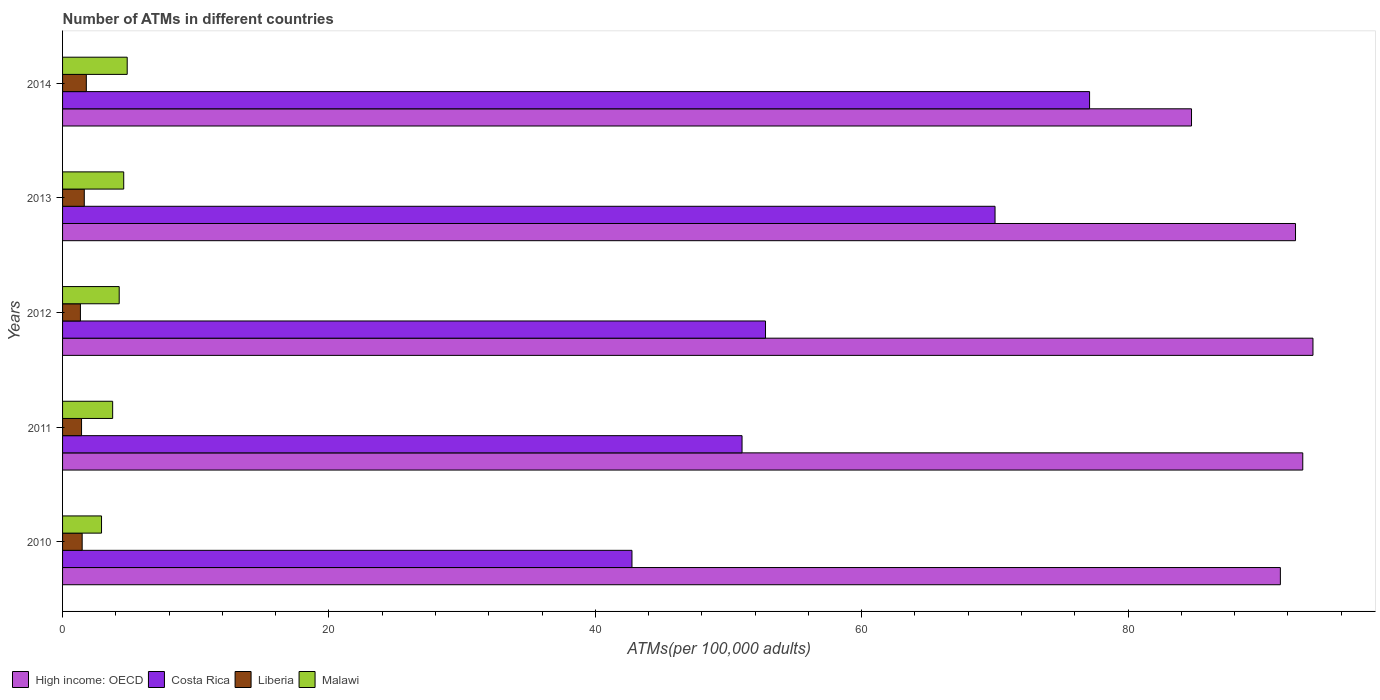Are the number of bars per tick equal to the number of legend labels?
Offer a very short reply. Yes. In how many cases, is the number of bars for a given year not equal to the number of legend labels?
Offer a very short reply. 0. What is the number of ATMs in Liberia in 2010?
Provide a short and direct response. 1.47. Across all years, what is the maximum number of ATMs in Malawi?
Provide a succinct answer. 4.85. Across all years, what is the minimum number of ATMs in Liberia?
Ensure brevity in your answer.  1.34. In which year was the number of ATMs in High income: OECD maximum?
Keep it short and to the point. 2012. What is the total number of ATMs in Liberia in the graph?
Provide a succinct answer. 7.65. What is the difference between the number of ATMs in Liberia in 2011 and that in 2013?
Offer a very short reply. -0.21. What is the difference between the number of ATMs in Malawi in 2014 and the number of ATMs in High income: OECD in 2013?
Provide a succinct answer. -87.72. What is the average number of ATMs in Liberia per year?
Make the answer very short. 1.53. In the year 2012, what is the difference between the number of ATMs in Liberia and number of ATMs in High income: OECD?
Ensure brevity in your answer.  -92.54. What is the ratio of the number of ATMs in Malawi in 2011 to that in 2013?
Keep it short and to the point. 0.82. What is the difference between the highest and the second highest number of ATMs in Liberia?
Give a very brief answer. 0.15. What is the difference between the highest and the lowest number of ATMs in Costa Rica?
Your answer should be very brief. 34.36. In how many years, is the number of ATMs in Costa Rica greater than the average number of ATMs in Costa Rica taken over all years?
Provide a short and direct response. 2. Is the sum of the number of ATMs in Costa Rica in 2011 and 2014 greater than the maximum number of ATMs in Liberia across all years?
Give a very brief answer. Yes. What does the 1st bar from the top in 2014 represents?
Ensure brevity in your answer.  Malawi. What does the 4th bar from the bottom in 2014 represents?
Your answer should be compact. Malawi. Is it the case that in every year, the sum of the number of ATMs in Malawi and number of ATMs in Costa Rica is greater than the number of ATMs in High income: OECD?
Your response must be concise. No. How many years are there in the graph?
Your response must be concise. 5. What is the difference between two consecutive major ticks on the X-axis?
Provide a short and direct response. 20. Are the values on the major ticks of X-axis written in scientific E-notation?
Provide a succinct answer. No. Does the graph contain grids?
Ensure brevity in your answer.  No. Where does the legend appear in the graph?
Offer a very short reply. Bottom left. How many legend labels are there?
Your answer should be compact. 4. How are the legend labels stacked?
Your answer should be very brief. Horizontal. What is the title of the graph?
Your response must be concise. Number of ATMs in different countries. Does "Austria" appear as one of the legend labels in the graph?
Your answer should be compact. No. What is the label or title of the X-axis?
Provide a short and direct response. ATMs(per 100,0 adults). What is the label or title of the Y-axis?
Offer a very short reply. Years. What is the ATMs(per 100,000 adults) in High income: OECD in 2010?
Provide a short and direct response. 91.44. What is the ATMs(per 100,000 adults) of Costa Rica in 2010?
Provide a succinct answer. 42.75. What is the ATMs(per 100,000 adults) of Liberia in 2010?
Offer a terse response. 1.47. What is the ATMs(per 100,000 adults) in Malawi in 2010?
Give a very brief answer. 2.93. What is the ATMs(per 100,000 adults) in High income: OECD in 2011?
Make the answer very short. 93.12. What is the ATMs(per 100,000 adults) of Costa Rica in 2011?
Ensure brevity in your answer.  51.02. What is the ATMs(per 100,000 adults) of Liberia in 2011?
Make the answer very short. 1.42. What is the ATMs(per 100,000 adults) of Malawi in 2011?
Provide a succinct answer. 3.76. What is the ATMs(per 100,000 adults) of High income: OECD in 2012?
Provide a succinct answer. 93.88. What is the ATMs(per 100,000 adults) in Costa Rica in 2012?
Offer a very short reply. 52.78. What is the ATMs(per 100,000 adults) in Liberia in 2012?
Keep it short and to the point. 1.34. What is the ATMs(per 100,000 adults) in Malawi in 2012?
Offer a terse response. 4.25. What is the ATMs(per 100,000 adults) of High income: OECD in 2013?
Make the answer very short. 92.57. What is the ATMs(per 100,000 adults) of Costa Rica in 2013?
Provide a short and direct response. 70.01. What is the ATMs(per 100,000 adults) in Liberia in 2013?
Provide a succinct answer. 1.63. What is the ATMs(per 100,000 adults) of Malawi in 2013?
Ensure brevity in your answer.  4.59. What is the ATMs(per 100,000 adults) of High income: OECD in 2014?
Make the answer very short. 84.77. What is the ATMs(per 100,000 adults) of Costa Rica in 2014?
Keep it short and to the point. 77.11. What is the ATMs(per 100,000 adults) of Liberia in 2014?
Provide a succinct answer. 1.78. What is the ATMs(per 100,000 adults) in Malawi in 2014?
Your response must be concise. 4.85. Across all years, what is the maximum ATMs(per 100,000 adults) in High income: OECD?
Give a very brief answer. 93.88. Across all years, what is the maximum ATMs(per 100,000 adults) of Costa Rica?
Your response must be concise. 77.11. Across all years, what is the maximum ATMs(per 100,000 adults) of Liberia?
Provide a succinct answer. 1.78. Across all years, what is the maximum ATMs(per 100,000 adults) in Malawi?
Provide a short and direct response. 4.85. Across all years, what is the minimum ATMs(per 100,000 adults) in High income: OECD?
Provide a succinct answer. 84.77. Across all years, what is the minimum ATMs(per 100,000 adults) in Costa Rica?
Give a very brief answer. 42.75. Across all years, what is the minimum ATMs(per 100,000 adults) of Liberia?
Provide a succinct answer. 1.34. Across all years, what is the minimum ATMs(per 100,000 adults) in Malawi?
Your answer should be very brief. 2.93. What is the total ATMs(per 100,000 adults) in High income: OECD in the graph?
Your response must be concise. 455.78. What is the total ATMs(per 100,000 adults) in Costa Rica in the graph?
Give a very brief answer. 293.68. What is the total ATMs(per 100,000 adults) of Liberia in the graph?
Provide a succinct answer. 7.65. What is the total ATMs(per 100,000 adults) in Malawi in the graph?
Make the answer very short. 20.38. What is the difference between the ATMs(per 100,000 adults) of High income: OECD in 2010 and that in 2011?
Give a very brief answer. -1.68. What is the difference between the ATMs(per 100,000 adults) in Costa Rica in 2010 and that in 2011?
Provide a succinct answer. -8.26. What is the difference between the ATMs(per 100,000 adults) of Liberia in 2010 and that in 2011?
Ensure brevity in your answer.  0.05. What is the difference between the ATMs(per 100,000 adults) in Malawi in 2010 and that in 2011?
Ensure brevity in your answer.  -0.84. What is the difference between the ATMs(per 100,000 adults) in High income: OECD in 2010 and that in 2012?
Your response must be concise. -2.45. What is the difference between the ATMs(per 100,000 adults) in Costa Rica in 2010 and that in 2012?
Keep it short and to the point. -10.03. What is the difference between the ATMs(per 100,000 adults) in Liberia in 2010 and that in 2012?
Offer a very short reply. 0.13. What is the difference between the ATMs(per 100,000 adults) in Malawi in 2010 and that in 2012?
Your response must be concise. -1.33. What is the difference between the ATMs(per 100,000 adults) of High income: OECD in 2010 and that in 2013?
Provide a succinct answer. -1.14. What is the difference between the ATMs(per 100,000 adults) of Costa Rica in 2010 and that in 2013?
Offer a terse response. -27.26. What is the difference between the ATMs(per 100,000 adults) of Liberia in 2010 and that in 2013?
Your response must be concise. -0.16. What is the difference between the ATMs(per 100,000 adults) in Malawi in 2010 and that in 2013?
Give a very brief answer. -1.67. What is the difference between the ATMs(per 100,000 adults) of High income: OECD in 2010 and that in 2014?
Give a very brief answer. 6.67. What is the difference between the ATMs(per 100,000 adults) in Costa Rica in 2010 and that in 2014?
Give a very brief answer. -34.36. What is the difference between the ATMs(per 100,000 adults) of Liberia in 2010 and that in 2014?
Offer a very short reply. -0.31. What is the difference between the ATMs(per 100,000 adults) in Malawi in 2010 and that in 2014?
Offer a terse response. -1.93. What is the difference between the ATMs(per 100,000 adults) in High income: OECD in 2011 and that in 2012?
Make the answer very short. -0.77. What is the difference between the ATMs(per 100,000 adults) in Costa Rica in 2011 and that in 2012?
Offer a terse response. -1.76. What is the difference between the ATMs(per 100,000 adults) of Liberia in 2011 and that in 2012?
Offer a very short reply. 0.08. What is the difference between the ATMs(per 100,000 adults) of Malawi in 2011 and that in 2012?
Offer a very short reply. -0.49. What is the difference between the ATMs(per 100,000 adults) of High income: OECD in 2011 and that in 2013?
Give a very brief answer. 0.54. What is the difference between the ATMs(per 100,000 adults) in Costa Rica in 2011 and that in 2013?
Provide a short and direct response. -19. What is the difference between the ATMs(per 100,000 adults) of Liberia in 2011 and that in 2013?
Provide a succinct answer. -0.21. What is the difference between the ATMs(per 100,000 adults) in Malawi in 2011 and that in 2013?
Make the answer very short. -0.83. What is the difference between the ATMs(per 100,000 adults) in High income: OECD in 2011 and that in 2014?
Provide a succinct answer. 8.35. What is the difference between the ATMs(per 100,000 adults) in Costa Rica in 2011 and that in 2014?
Provide a succinct answer. -26.09. What is the difference between the ATMs(per 100,000 adults) of Liberia in 2011 and that in 2014?
Ensure brevity in your answer.  -0.36. What is the difference between the ATMs(per 100,000 adults) of Malawi in 2011 and that in 2014?
Make the answer very short. -1.09. What is the difference between the ATMs(per 100,000 adults) in High income: OECD in 2012 and that in 2013?
Ensure brevity in your answer.  1.31. What is the difference between the ATMs(per 100,000 adults) in Costa Rica in 2012 and that in 2013?
Make the answer very short. -17.23. What is the difference between the ATMs(per 100,000 adults) in Liberia in 2012 and that in 2013?
Give a very brief answer. -0.29. What is the difference between the ATMs(per 100,000 adults) in Malawi in 2012 and that in 2013?
Provide a short and direct response. -0.34. What is the difference between the ATMs(per 100,000 adults) of High income: OECD in 2012 and that in 2014?
Your answer should be compact. 9.12. What is the difference between the ATMs(per 100,000 adults) in Costa Rica in 2012 and that in 2014?
Make the answer very short. -24.33. What is the difference between the ATMs(per 100,000 adults) of Liberia in 2012 and that in 2014?
Provide a succinct answer. -0.44. What is the difference between the ATMs(per 100,000 adults) of Malawi in 2012 and that in 2014?
Your answer should be compact. -0.6. What is the difference between the ATMs(per 100,000 adults) of High income: OECD in 2013 and that in 2014?
Keep it short and to the point. 7.81. What is the difference between the ATMs(per 100,000 adults) in Costa Rica in 2013 and that in 2014?
Provide a succinct answer. -7.1. What is the difference between the ATMs(per 100,000 adults) in Liberia in 2013 and that in 2014?
Offer a very short reply. -0.15. What is the difference between the ATMs(per 100,000 adults) in Malawi in 2013 and that in 2014?
Make the answer very short. -0.26. What is the difference between the ATMs(per 100,000 adults) in High income: OECD in 2010 and the ATMs(per 100,000 adults) in Costa Rica in 2011?
Your answer should be compact. 40.42. What is the difference between the ATMs(per 100,000 adults) in High income: OECD in 2010 and the ATMs(per 100,000 adults) in Liberia in 2011?
Provide a short and direct response. 90.01. What is the difference between the ATMs(per 100,000 adults) of High income: OECD in 2010 and the ATMs(per 100,000 adults) of Malawi in 2011?
Ensure brevity in your answer.  87.68. What is the difference between the ATMs(per 100,000 adults) in Costa Rica in 2010 and the ATMs(per 100,000 adults) in Liberia in 2011?
Your answer should be very brief. 41.33. What is the difference between the ATMs(per 100,000 adults) in Costa Rica in 2010 and the ATMs(per 100,000 adults) in Malawi in 2011?
Offer a terse response. 38.99. What is the difference between the ATMs(per 100,000 adults) in Liberia in 2010 and the ATMs(per 100,000 adults) in Malawi in 2011?
Offer a terse response. -2.29. What is the difference between the ATMs(per 100,000 adults) in High income: OECD in 2010 and the ATMs(per 100,000 adults) in Costa Rica in 2012?
Your answer should be very brief. 38.66. What is the difference between the ATMs(per 100,000 adults) of High income: OECD in 2010 and the ATMs(per 100,000 adults) of Liberia in 2012?
Provide a short and direct response. 90.1. What is the difference between the ATMs(per 100,000 adults) in High income: OECD in 2010 and the ATMs(per 100,000 adults) in Malawi in 2012?
Offer a very short reply. 87.18. What is the difference between the ATMs(per 100,000 adults) in Costa Rica in 2010 and the ATMs(per 100,000 adults) in Liberia in 2012?
Offer a very short reply. 41.41. What is the difference between the ATMs(per 100,000 adults) of Costa Rica in 2010 and the ATMs(per 100,000 adults) of Malawi in 2012?
Ensure brevity in your answer.  38.5. What is the difference between the ATMs(per 100,000 adults) of Liberia in 2010 and the ATMs(per 100,000 adults) of Malawi in 2012?
Ensure brevity in your answer.  -2.78. What is the difference between the ATMs(per 100,000 adults) in High income: OECD in 2010 and the ATMs(per 100,000 adults) in Costa Rica in 2013?
Provide a short and direct response. 21.42. What is the difference between the ATMs(per 100,000 adults) of High income: OECD in 2010 and the ATMs(per 100,000 adults) of Liberia in 2013?
Offer a very short reply. 89.81. What is the difference between the ATMs(per 100,000 adults) in High income: OECD in 2010 and the ATMs(per 100,000 adults) in Malawi in 2013?
Keep it short and to the point. 86.85. What is the difference between the ATMs(per 100,000 adults) of Costa Rica in 2010 and the ATMs(per 100,000 adults) of Liberia in 2013?
Provide a succinct answer. 41.12. What is the difference between the ATMs(per 100,000 adults) in Costa Rica in 2010 and the ATMs(per 100,000 adults) in Malawi in 2013?
Your answer should be compact. 38.16. What is the difference between the ATMs(per 100,000 adults) of Liberia in 2010 and the ATMs(per 100,000 adults) of Malawi in 2013?
Give a very brief answer. -3.12. What is the difference between the ATMs(per 100,000 adults) of High income: OECD in 2010 and the ATMs(per 100,000 adults) of Costa Rica in 2014?
Give a very brief answer. 14.33. What is the difference between the ATMs(per 100,000 adults) of High income: OECD in 2010 and the ATMs(per 100,000 adults) of Liberia in 2014?
Give a very brief answer. 89.65. What is the difference between the ATMs(per 100,000 adults) of High income: OECD in 2010 and the ATMs(per 100,000 adults) of Malawi in 2014?
Ensure brevity in your answer.  86.58. What is the difference between the ATMs(per 100,000 adults) in Costa Rica in 2010 and the ATMs(per 100,000 adults) in Liberia in 2014?
Your answer should be compact. 40.97. What is the difference between the ATMs(per 100,000 adults) in Costa Rica in 2010 and the ATMs(per 100,000 adults) in Malawi in 2014?
Offer a terse response. 37.9. What is the difference between the ATMs(per 100,000 adults) of Liberia in 2010 and the ATMs(per 100,000 adults) of Malawi in 2014?
Your response must be concise. -3.38. What is the difference between the ATMs(per 100,000 adults) of High income: OECD in 2011 and the ATMs(per 100,000 adults) of Costa Rica in 2012?
Make the answer very short. 40.34. What is the difference between the ATMs(per 100,000 adults) in High income: OECD in 2011 and the ATMs(per 100,000 adults) in Liberia in 2012?
Offer a very short reply. 91.78. What is the difference between the ATMs(per 100,000 adults) in High income: OECD in 2011 and the ATMs(per 100,000 adults) in Malawi in 2012?
Keep it short and to the point. 88.87. What is the difference between the ATMs(per 100,000 adults) in Costa Rica in 2011 and the ATMs(per 100,000 adults) in Liberia in 2012?
Ensure brevity in your answer.  49.68. What is the difference between the ATMs(per 100,000 adults) in Costa Rica in 2011 and the ATMs(per 100,000 adults) in Malawi in 2012?
Provide a short and direct response. 46.77. What is the difference between the ATMs(per 100,000 adults) in Liberia in 2011 and the ATMs(per 100,000 adults) in Malawi in 2012?
Provide a short and direct response. -2.83. What is the difference between the ATMs(per 100,000 adults) in High income: OECD in 2011 and the ATMs(per 100,000 adults) in Costa Rica in 2013?
Provide a succinct answer. 23.1. What is the difference between the ATMs(per 100,000 adults) of High income: OECD in 2011 and the ATMs(per 100,000 adults) of Liberia in 2013?
Your answer should be compact. 91.49. What is the difference between the ATMs(per 100,000 adults) in High income: OECD in 2011 and the ATMs(per 100,000 adults) in Malawi in 2013?
Offer a very short reply. 88.53. What is the difference between the ATMs(per 100,000 adults) in Costa Rica in 2011 and the ATMs(per 100,000 adults) in Liberia in 2013?
Give a very brief answer. 49.39. What is the difference between the ATMs(per 100,000 adults) in Costa Rica in 2011 and the ATMs(per 100,000 adults) in Malawi in 2013?
Give a very brief answer. 46.43. What is the difference between the ATMs(per 100,000 adults) of Liberia in 2011 and the ATMs(per 100,000 adults) of Malawi in 2013?
Provide a short and direct response. -3.17. What is the difference between the ATMs(per 100,000 adults) of High income: OECD in 2011 and the ATMs(per 100,000 adults) of Costa Rica in 2014?
Offer a terse response. 16.01. What is the difference between the ATMs(per 100,000 adults) in High income: OECD in 2011 and the ATMs(per 100,000 adults) in Liberia in 2014?
Ensure brevity in your answer.  91.33. What is the difference between the ATMs(per 100,000 adults) in High income: OECD in 2011 and the ATMs(per 100,000 adults) in Malawi in 2014?
Your answer should be very brief. 88.27. What is the difference between the ATMs(per 100,000 adults) of Costa Rica in 2011 and the ATMs(per 100,000 adults) of Liberia in 2014?
Your answer should be compact. 49.23. What is the difference between the ATMs(per 100,000 adults) in Costa Rica in 2011 and the ATMs(per 100,000 adults) in Malawi in 2014?
Offer a very short reply. 46.16. What is the difference between the ATMs(per 100,000 adults) in Liberia in 2011 and the ATMs(per 100,000 adults) in Malawi in 2014?
Provide a succinct answer. -3.43. What is the difference between the ATMs(per 100,000 adults) in High income: OECD in 2012 and the ATMs(per 100,000 adults) in Costa Rica in 2013?
Your response must be concise. 23.87. What is the difference between the ATMs(per 100,000 adults) in High income: OECD in 2012 and the ATMs(per 100,000 adults) in Liberia in 2013?
Give a very brief answer. 92.25. What is the difference between the ATMs(per 100,000 adults) in High income: OECD in 2012 and the ATMs(per 100,000 adults) in Malawi in 2013?
Offer a very short reply. 89.29. What is the difference between the ATMs(per 100,000 adults) in Costa Rica in 2012 and the ATMs(per 100,000 adults) in Liberia in 2013?
Keep it short and to the point. 51.15. What is the difference between the ATMs(per 100,000 adults) of Costa Rica in 2012 and the ATMs(per 100,000 adults) of Malawi in 2013?
Make the answer very short. 48.19. What is the difference between the ATMs(per 100,000 adults) of Liberia in 2012 and the ATMs(per 100,000 adults) of Malawi in 2013?
Your answer should be very brief. -3.25. What is the difference between the ATMs(per 100,000 adults) in High income: OECD in 2012 and the ATMs(per 100,000 adults) in Costa Rica in 2014?
Ensure brevity in your answer.  16.77. What is the difference between the ATMs(per 100,000 adults) of High income: OECD in 2012 and the ATMs(per 100,000 adults) of Liberia in 2014?
Provide a short and direct response. 92.1. What is the difference between the ATMs(per 100,000 adults) of High income: OECD in 2012 and the ATMs(per 100,000 adults) of Malawi in 2014?
Offer a very short reply. 89.03. What is the difference between the ATMs(per 100,000 adults) of Costa Rica in 2012 and the ATMs(per 100,000 adults) of Liberia in 2014?
Offer a terse response. 51. What is the difference between the ATMs(per 100,000 adults) of Costa Rica in 2012 and the ATMs(per 100,000 adults) of Malawi in 2014?
Ensure brevity in your answer.  47.93. What is the difference between the ATMs(per 100,000 adults) of Liberia in 2012 and the ATMs(per 100,000 adults) of Malawi in 2014?
Provide a succinct answer. -3.51. What is the difference between the ATMs(per 100,000 adults) in High income: OECD in 2013 and the ATMs(per 100,000 adults) in Costa Rica in 2014?
Provide a succinct answer. 15.46. What is the difference between the ATMs(per 100,000 adults) in High income: OECD in 2013 and the ATMs(per 100,000 adults) in Liberia in 2014?
Your answer should be very brief. 90.79. What is the difference between the ATMs(per 100,000 adults) in High income: OECD in 2013 and the ATMs(per 100,000 adults) in Malawi in 2014?
Your response must be concise. 87.72. What is the difference between the ATMs(per 100,000 adults) of Costa Rica in 2013 and the ATMs(per 100,000 adults) of Liberia in 2014?
Make the answer very short. 68.23. What is the difference between the ATMs(per 100,000 adults) in Costa Rica in 2013 and the ATMs(per 100,000 adults) in Malawi in 2014?
Ensure brevity in your answer.  65.16. What is the difference between the ATMs(per 100,000 adults) in Liberia in 2013 and the ATMs(per 100,000 adults) in Malawi in 2014?
Provide a succinct answer. -3.22. What is the average ATMs(per 100,000 adults) in High income: OECD per year?
Offer a very short reply. 91.16. What is the average ATMs(per 100,000 adults) in Costa Rica per year?
Keep it short and to the point. 58.73. What is the average ATMs(per 100,000 adults) in Liberia per year?
Your answer should be compact. 1.53. What is the average ATMs(per 100,000 adults) in Malawi per year?
Provide a short and direct response. 4.08. In the year 2010, what is the difference between the ATMs(per 100,000 adults) of High income: OECD and ATMs(per 100,000 adults) of Costa Rica?
Your answer should be compact. 48.68. In the year 2010, what is the difference between the ATMs(per 100,000 adults) of High income: OECD and ATMs(per 100,000 adults) of Liberia?
Provide a short and direct response. 89.97. In the year 2010, what is the difference between the ATMs(per 100,000 adults) in High income: OECD and ATMs(per 100,000 adults) in Malawi?
Your response must be concise. 88.51. In the year 2010, what is the difference between the ATMs(per 100,000 adults) of Costa Rica and ATMs(per 100,000 adults) of Liberia?
Make the answer very short. 41.28. In the year 2010, what is the difference between the ATMs(per 100,000 adults) in Costa Rica and ATMs(per 100,000 adults) in Malawi?
Provide a short and direct response. 39.83. In the year 2010, what is the difference between the ATMs(per 100,000 adults) of Liberia and ATMs(per 100,000 adults) of Malawi?
Your response must be concise. -1.45. In the year 2011, what is the difference between the ATMs(per 100,000 adults) of High income: OECD and ATMs(per 100,000 adults) of Costa Rica?
Provide a succinct answer. 42.1. In the year 2011, what is the difference between the ATMs(per 100,000 adults) in High income: OECD and ATMs(per 100,000 adults) in Liberia?
Your answer should be compact. 91.69. In the year 2011, what is the difference between the ATMs(per 100,000 adults) of High income: OECD and ATMs(per 100,000 adults) of Malawi?
Ensure brevity in your answer.  89.36. In the year 2011, what is the difference between the ATMs(per 100,000 adults) of Costa Rica and ATMs(per 100,000 adults) of Liberia?
Give a very brief answer. 49.59. In the year 2011, what is the difference between the ATMs(per 100,000 adults) of Costa Rica and ATMs(per 100,000 adults) of Malawi?
Your answer should be very brief. 47.26. In the year 2011, what is the difference between the ATMs(per 100,000 adults) of Liberia and ATMs(per 100,000 adults) of Malawi?
Give a very brief answer. -2.34. In the year 2012, what is the difference between the ATMs(per 100,000 adults) of High income: OECD and ATMs(per 100,000 adults) of Costa Rica?
Provide a short and direct response. 41.1. In the year 2012, what is the difference between the ATMs(per 100,000 adults) of High income: OECD and ATMs(per 100,000 adults) of Liberia?
Keep it short and to the point. 92.54. In the year 2012, what is the difference between the ATMs(per 100,000 adults) in High income: OECD and ATMs(per 100,000 adults) in Malawi?
Provide a succinct answer. 89.63. In the year 2012, what is the difference between the ATMs(per 100,000 adults) of Costa Rica and ATMs(per 100,000 adults) of Liberia?
Provide a short and direct response. 51.44. In the year 2012, what is the difference between the ATMs(per 100,000 adults) of Costa Rica and ATMs(per 100,000 adults) of Malawi?
Provide a short and direct response. 48.53. In the year 2012, what is the difference between the ATMs(per 100,000 adults) of Liberia and ATMs(per 100,000 adults) of Malawi?
Your response must be concise. -2.91. In the year 2013, what is the difference between the ATMs(per 100,000 adults) of High income: OECD and ATMs(per 100,000 adults) of Costa Rica?
Ensure brevity in your answer.  22.56. In the year 2013, what is the difference between the ATMs(per 100,000 adults) in High income: OECD and ATMs(per 100,000 adults) in Liberia?
Provide a short and direct response. 90.94. In the year 2013, what is the difference between the ATMs(per 100,000 adults) in High income: OECD and ATMs(per 100,000 adults) in Malawi?
Your response must be concise. 87.98. In the year 2013, what is the difference between the ATMs(per 100,000 adults) of Costa Rica and ATMs(per 100,000 adults) of Liberia?
Your answer should be compact. 68.38. In the year 2013, what is the difference between the ATMs(per 100,000 adults) of Costa Rica and ATMs(per 100,000 adults) of Malawi?
Your answer should be very brief. 65.42. In the year 2013, what is the difference between the ATMs(per 100,000 adults) of Liberia and ATMs(per 100,000 adults) of Malawi?
Provide a succinct answer. -2.96. In the year 2014, what is the difference between the ATMs(per 100,000 adults) of High income: OECD and ATMs(per 100,000 adults) of Costa Rica?
Make the answer very short. 7.65. In the year 2014, what is the difference between the ATMs(per 100,000 adults) of High income: OECD and ATMs(per 100,000 adults) of Liberia?
Ensure brevity in your answer.  82.98. In the year 2014, what is the difference between the ATMs(per 100,000 adults) of High income: OECD and ATMs(per 100,000 adults) of Malawi?
Provide a short and direct response. 79.91. In the year 2014, what is the difference between the ATMs(per 100,000 adults) in Costa Rica and ATMs(per 100,000 adults) in Liberia?
Give a very brief answer. 75.33. In the year 2014, what is the difference between the ATMs(per 100,000 adults) of Costa Rica and ATMs(per 100,000 adults) of Malawi?
Offer a terse response. 72.26. In the year 2014, what is the difference between the ATMs(per 100,000 adults) in Liberia and ATMs(per 100,000 adults) in Malawi?
Give a very brief answer. -3.07. What is the ratio of the ATMs(per 100,000 adults) of High income: OECD in 2010 to that in 2011?
Ensure brevity in your answer.  0.98. What is the ratio of the ATMs(per 100,000 adults) of Costa Rica in 2010 to that in 2011?
Your answer should be very brief. 0.84. What is the ratio of the ATMs(per 100,000 adults) of Liberia in 2010 to that in 2011?
Give a very brief answer. 1.03. What is the ratio of the ATMs(per 100,000 adults) in High income: OECD in 2010 to that in 2012?
Your response must be concise. 0.97. What is the ratio of the ATMs(per 100,000 adults) of Costa Rica in 2010 to that in 2012?
Make the answer very short. 0.81. What is the ratio of the ATMs(per 100,000 adults) in Liberia in 2010 to that in 2012?
Make the answer very short. 1.1. What is the ratio of the ATMs(per 100,000 adults) of Malawi in 2010 to that in 2012?
Provide a succinct answer. 0.69. What is the ratio of the ATMs(per 100,000 adults) of High income: OECD in 2010 to that in 2013?
Your answer should be compact. 0.99. What is the ratio of the ATMs(per 100,000 adults) of Costa Rica in 2010 to that in 2013?
Your answer should be very brief. 0.61. What is the ratio of the ATMs(per 100,000 adults) of Liberia in 2010 to that in 2013?
Offer a very short reply. 0.9. What is the ratio of the ATMs(per 100,000 adults) of Malawi in 2010 to that in 2013?
Offer a terse response. 0.64. What is the ratio of the ATMs(per 100,000 adults) in High income: OECD in 2010 to that in 2014?
Your answer should be very brief. 1.08. What is the ratio of the ATMs(per 100,000 adults) of Costa Rica in 2010 to that in 2014?
Offer a terse response. 0.55. What is the ratio of the ATMs(per 100,000 adults) in Liberia in 2010 to that in 2014?
Give a very brief answer. 0.83. What is the ratio of the ATMs(per 100,000 adults) of Malawi in 2010 to that in 2014?
Your response must be concise. 0.6. What is the ratio of the ATMs(per 100,000 adults) of High income: OECD in 2011 to that in 2012?
Make the answer very short. 0.99. What is the ratio of the ATMs(per 100,000 adults) in Costa Rica in 2011 to that in 2012?
Offer a terse response. 0.97. What is the ratio of the ATMs(per 100,000 adults) in Liberia in 2011 to that in 2012?
Give a very brief answer. 1.06. What is the ratio of the ATMs(per 100,000 adults) in Malawi in 2011 to that in 2012?
Provide a succinct answer. 0.88. What is the ratio of the ATMs(per 100,000 adults) of High income: OECD in 2011 to that in 2013?
Keep it short and to the point. 1.01. What is the ratio of the ATMs(per 100,000 adults) in Costa Rica in 2011 to that in 2013?
Provide a succinct answer. 0.73. What is the ratio of the ATMs(per 100,000 adults) of Liberia in 2011 to that in 2013?
Provide a short and direct response. 0.87. What is the ratio of the ATMs(per 100,000 adults) of Malawi in 2011 to that in 2013?
Your response must be concise. 0.82. What is the ratio of the ATMs(per 100,000 adults) in High income: OECD in 2011 to that in 2014?
Your answer should be compact. 1.1. What is the ratio of the ATMs(per 100,000 adults) of Costa Rica in 2011 to that in 2014?
Offer a very short reply. 0.66. What is the ratio of the ATMs(per 100,000 adults) in Liberia in 2011 to that in 2014?
Make the answer very short. 0.8. What is the ratio of the ATMs(per 100,000 adults) of Malawi in 2011 to that in 2014?
Your answer should be compact. 0.78. What is the ratio of the ATMs(per 100,000 adults) in High income: OECD in 2012 to that in 2013?
Ensure brevity in your answer.  1.01. What is the ratio of the ATMs(per 100,000 adults) in Costa Rica in 2012 to that in 2013?
Offer a very short reply. 0.75. What is the ratio of the ATMs(per 100,000 adults) in Liberia in 2012 to that in 2013?
Provide a succinct answer. 0.82. What is the ratio of the ATMs(per 100,000 adults) in Malawi in 2012 to that in 2013?
Provide a succinct answer. 0.93. What is the ratio of the ATMs(per 100,000 adults) in High income: OECD in 2012 to that in 2014?
Offer a terse response. 1.11. What is the ratio of the ATMs(per 100,000 adults) in Costa Rica in 2012 to that in 2014?
Make the answer very short. 0.68. What is the ratio of the ATMs(per 100,000 adults) in Liberia in 2012 to that in 2014?
Provide a short and direct response. 0.75. What is the ratio of the ATMs(per 100,000 adults) of Malawi in 2012 to that in 2014?
Provide a succinct answer. 0.88. What is the ratio of the ATMs(per 100,000 adults) of High income: OECD in 2013 to that in 2014?
Provide a short and direct response. 1.09. What is the ratio of the ATMs(per 100,000 adults) in Costa Rica in 2013 to that in 2014?
Give a very brief answer. 0.91. What is the ratio of the ATMs(per 100,000 adults) in Liberia in 2013 to that in 2014?
Your answer should be very brief. 0.91. What is the ratio of the ATMs(per 100,000 adults) of Malawi in 2013 to that in 2014?
Offer a terse response. 0.95. What is the difference between the highest and the second highest ATMs(per 100,000 adults) of High income: OECD?
Offer a terse response. 0.77. What is the difference between the highest and the second highest ATMs(per 100,000 adults) of Costa Rica?
Offer a very short reply. 7.1. What is the difference between the highest and the second highest ATMs(per 100,000 adults) in Liberia?
Ensure brevity in your answer.  0.15. What is the difference between the highest and the second highest ATMs(per 100,000 adults) of Malawi?
Your answer should be compact. 0.26. What is the difference between the highest and the lowest ATMs(per 100,000 adults) in High income: OECD?
Offer a very short reply. 9.12. What is the difference between the highest and the lowest ATMs(per 100,000 adults) in Costa Rica?
Keep it short and to the point. 34.36. What is the difference between the highest and the lowest ATMs(per 100,000 adults) in Liberia?
Your response must be concise. 0.44. What is the difference between the highest and the lowest ATMs(per 100,000 adults) in Malawi?
Give a very brief answer. 1.93. 